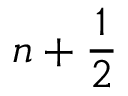Convert formula to latex. <formula><loc_0><loc_0><loc_500><loc_500>n + \frac { 1 } { 2 }</formula> 